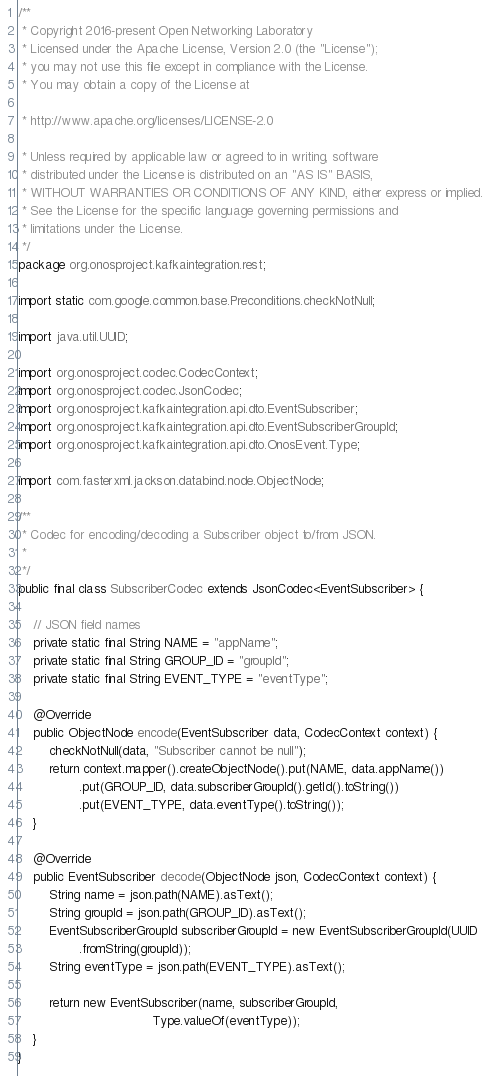Convert code to text. <code><loc_0><loc_0><loc_500><loc_500><_Java_>/**
 * Copyright 2016-present Open Networking Laboratory
 * Licensed under the Apache License, Version 2.0 (the "License");
 * you may not use this file except in compliance with the License.
 * You may obtain a copy of the License at

 * http://www.apache.org/licenses/LICENSE-2.0

 * Unless required by applicable law or agreed to in writing, software
 * distributed under the License is distributed on an "AS IS" BASIS,
 * WITHOUT WARRANTIES OR CONDITIONS OF ANY KIND, either express or implied.
 * See the License for the specific language governing permissions and
 * limitations under the License.
 */
package org.onosproject.kafkaintegration.rest;

import static com.google.common.base.Preconditions.checkNotNull;

import java.util.UUID;

import org.onosproject.codec.CodecContext;
import org.onosproject.codec.JsonCodec;
import org.onosproject.kafkaintegration.api.dto.EventSubscriber;
import org.onosproject.kafkaintegration.api.dto.EventSubscriberGroupId;
import org.onosproject.kafkaintegration.api.dto.OnosEvent.Type;

import com.fasterxml.jackson.databind.node.ObjectNode;

/**
 * Codec for encoding/decoding a Subscriber object to/from JSON.
 *
 */
public final class SubscriberCodec extends JsonCodec<EventSubscriber> {

    // JSON field names
    private static final String NAME = "appName";
    private static final String GROUP_ID = "groupId";
    private static final String EVENT_TYPE = "eventType";

    @Override
    public ObjectNode encode(EventSubscriber data, CodecContext context) {
        checkNotNull(data, "Subscriber cannot be null");
        return context.mapper().createObjectNode().put(NAME, data.appName())
                .put(GROUP_ID, data.subscriberGroupId().getId().toString())
                .put(EVENT_TYPE, data.eventType().toString());
    }

    @Override
    public EventSubscriber decode(ObjectNode json, CodecContext context) {
        String name = json.path(NAME).asText();
        String groupId = json.path(GROUP_ID).asText();
        EventSubscriberGroupId subscriberGroupId = new EventSubscriberGroupId(UUID
                .fromString(groupId));
        String eventType = json.path(EVENT_TYPE).asText();

        return new EventSubscriber(name, subscriberGroupId,
                                   Type.valueOf(eventType));
    }
}
</code> 